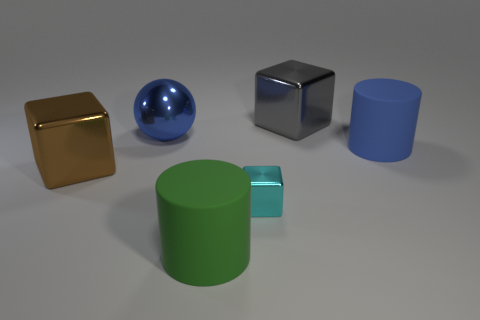Add 2 tiny green metal blocks. How many objects exist? 8 Subtract all balls. How many objects are left? 5 Add 4 metallic things. How many metallic things are left? 8 Add 2 big blue shiny things. How many big blue shiny things exist? 3 Subtract 0 purple balls. How many objects are left? 6 Subtract all green matte things. Subtract all big shiny spheres. How many objects are left? 4 